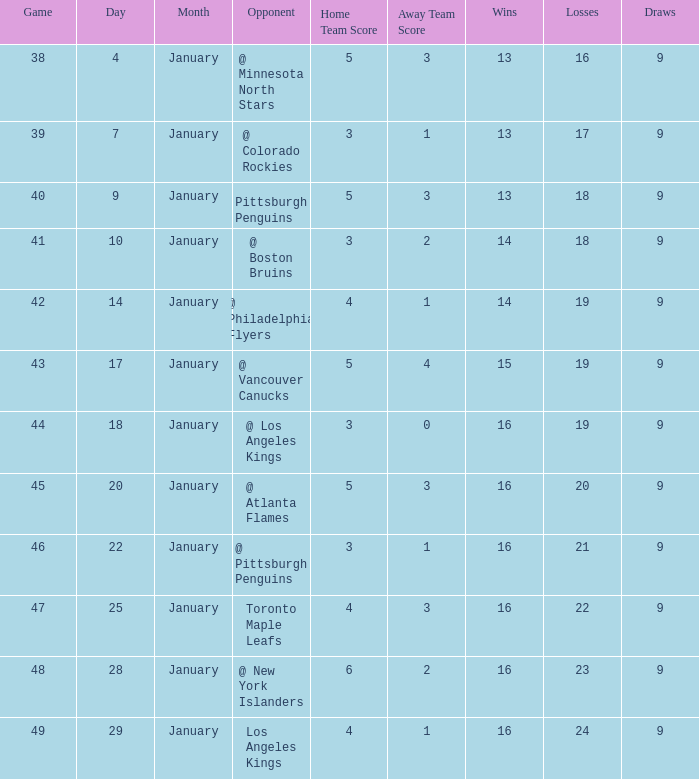What was the record after the game before Jan 7? 13-16-9. 